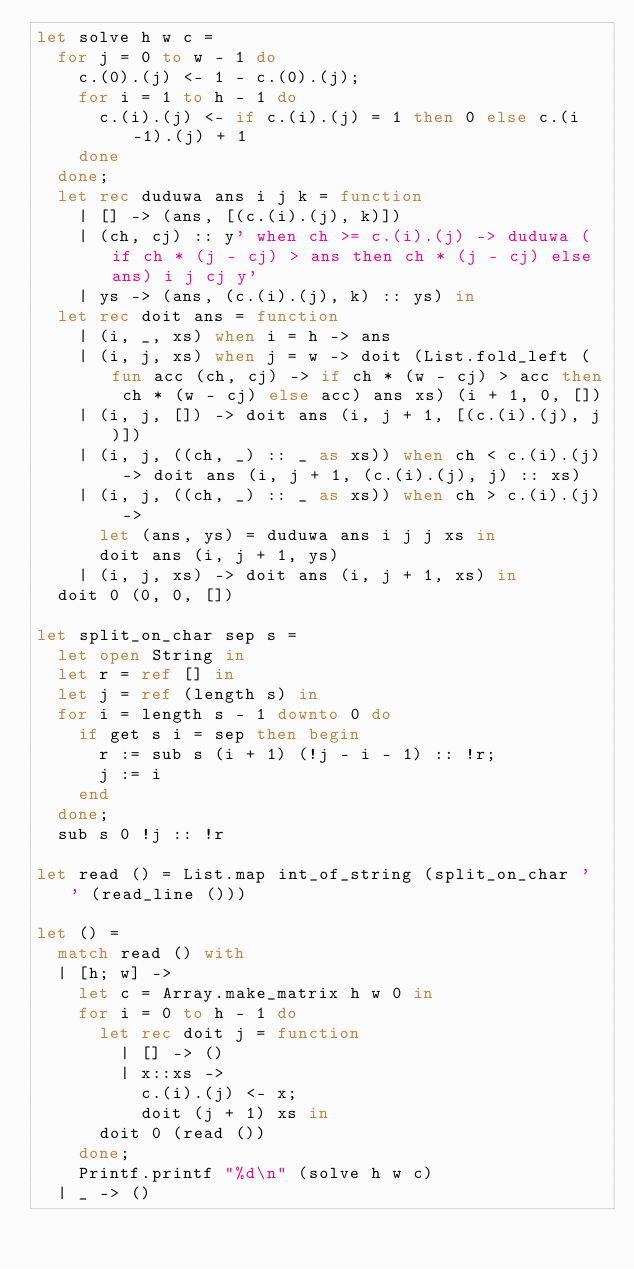Convert code to text. <code><loc_0><loc_0><loc_500><loc_500><_OCaml_>let solve h w c =
  for j = 0 to w - 1 do
    c.(0).(j) <- 1 - c.(0).(j);
    for i = 1 to h - 1 do
      c.(i).(j) <- if c.(i).(j) = 1 then 0 else c.(i-1).(j) + 1
    done
  done;
  let rec duduwa ans i j k = function
    | [] -> (ans, [(c.(i).(j), k)])
    | (ch, cj) :: y' when ch >= c.(i).(j) -> duduwa (if ch * (j - cj) > ans then ch * (j - cj) else ans) i j cj y'
    | ys -> (ans, (c.(i).(j), k) :: ys) in
  let rec doit ans = function
    | (i, _, xs) when i = h -> ans
    | (i, j, xs) when j = w -> doit (List.fold_left (fun acc (ch, cj) -> if ch * (w - cj) > acc then ch * (w - cj) else acc) ans xs) (i + 1, 0, [])
    | (i, j, []) -> doit ans (i, j + 1, [(c.(i).(j), j)])
    | (i, j, ((ch, _) :: _ as xs)) when ch < c.(i).(j) -> doit ans (i, j + 1, (c.(i).(j), j) :: xs)
    | (i, j, ((ch, _) :: _ as xs)) when ch > c.(i).(j) ->
      let (ans, ys) = duduwa ans i j j xs in
      doit ans (i, j + 1, ys)
    | (i, j, xs) -> doit ans (i, j + 1, xs) in
  doit 0 (0, 0, [])

let split_on_char sep s =
  let open String in
  let r = ref [] in
  let j = ref (length s) in
  for i = length s - 1 downto 0 do
    if get s i = sep then begin
      r := sub s (i + 1) (!j - i - 1) :: !r;
      j := i
    end
  done;
  sub s 0 !j :: !r

let read () = List.map int_of_string (split_on_char ' ' (read_line ()))

let () =
  match read () with
  | [h; w] ->
    let c = Array.make_matrix h w 0 in
    for i = 0 to h - 1 do
      let rec doit j = function
        | [] -> ()
        | x::xs ->
          c.(i).(j) <- x;
          doit (j + 1) xs in
      doit 0 (read ())
    done;
    Printf.printf "%d\n" (solve h w c)
  | _ -> ()</code> 